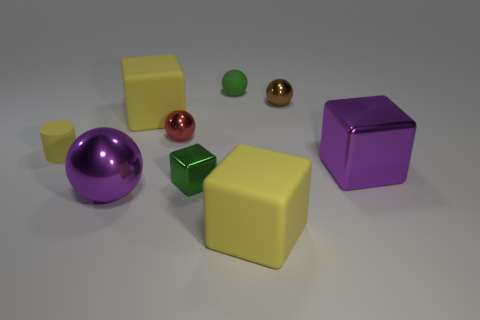What number of shiny things are both on the left side of the green metallic thing and right of the green sphere?
Give a very brief answer. 0. There is a green cube that is the same size as the red metallic ball; what is its material?
Your answer should be compact. Metal. There is a object that is in front of the big ball; is its size the same as the sphere in front of the tiny yellow matte object?
Provide a short and direct response. Yes. There is a brown shiny thing; are there any rubber things right of it?
Your answer should be very brief. No. There is a shiny cube that is right of the block in front of the large purple sphere; what color is it?
Your answer should be very brief. Purple. Are there fewer small metal cubes than large gray metallic blocks?
Make the answer very short. No. How many brown things are the same shape as the red object?
Your answer should be compact. 1. What is the color of the shiny sphere that is the same size as the red thing?
Make the answer very short. Brown. Are there an equal number of red objects behind the green matte object and big cubes in front of the red sphere?
Ensure brevity in your answer.  No. Are there any yellow cubes that have the same size as the yellow cylinder?
Keep it short and to the point. No. 